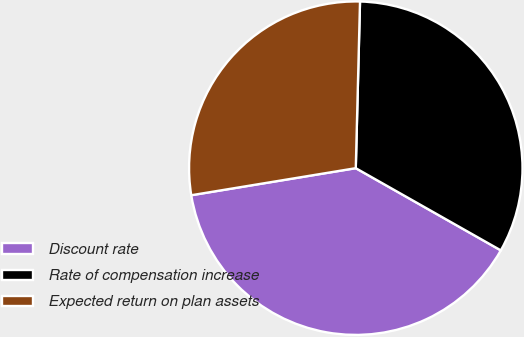Convert chart to OTSL. <chart><loc_0><loc_0><loc_500><loc_500><pie_chart><fcel>Discount rate<fcel>Rate of compensation increase<fcel>Expected return on plan assets<nl><fcel>39.2%<fcel>32.8%<fcel>28.0%<nl></chart> 